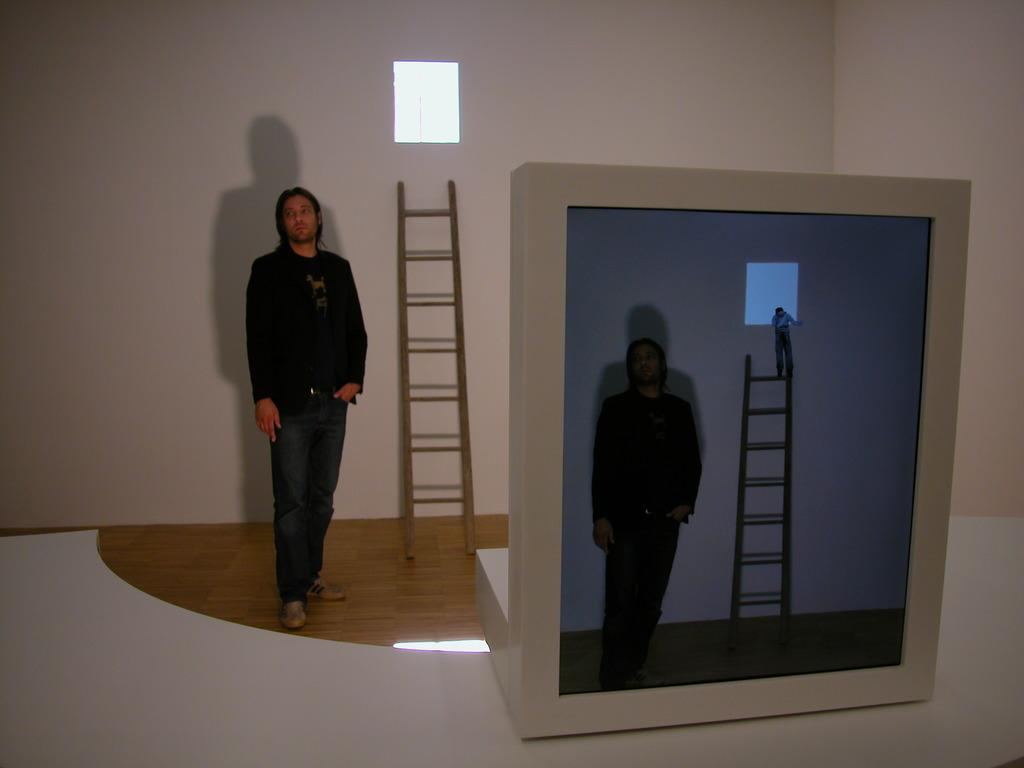What can be seen in the image? There is a person, a ladder, a wall with an object, a white-colored table, and a screen on the table. What is the person doing in the image? The facts provided do not specify what the person is doing. What is the object on the wall in the image? The facts provided do not specify what the object on the wall is. What is the screen on the table displaying? The facts provided do not specify what the screen is displaying. What type of comb is being used by the person in the image? There is no comb present in the image. What type of pot is visible on the table in the image? There is no pot present in the image. 